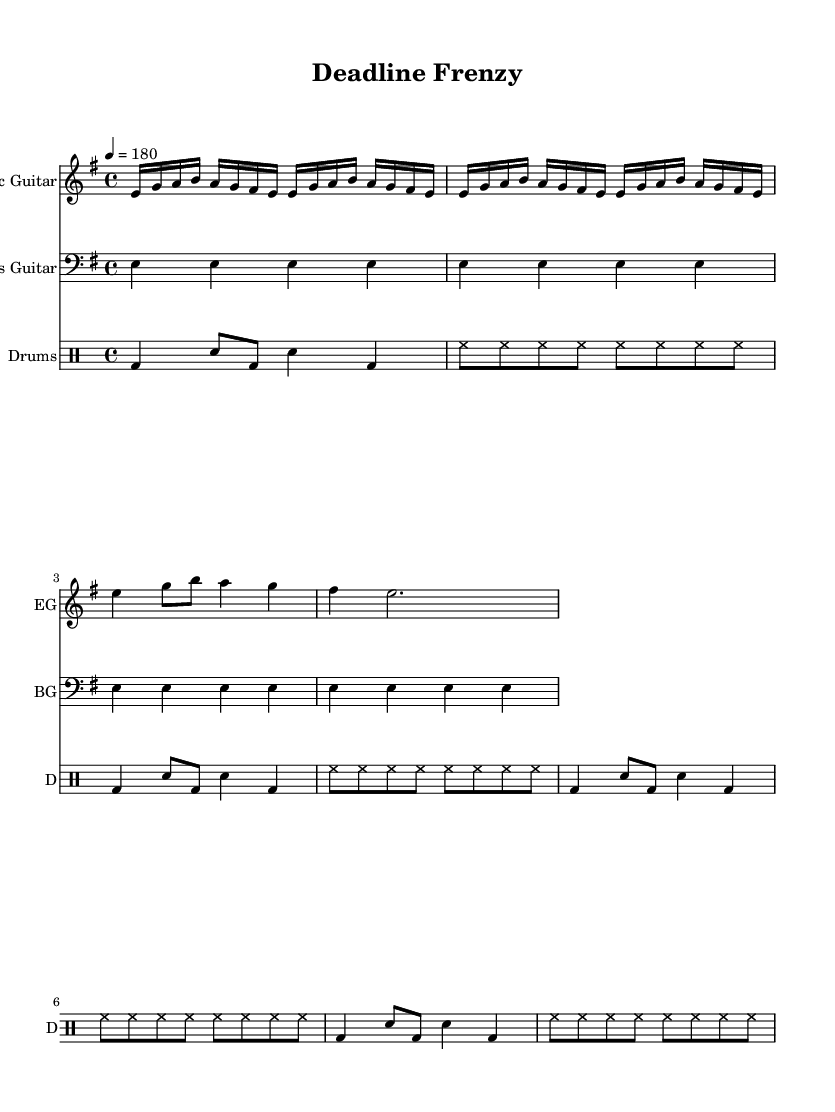What is the key signature of this music? The key signature shows one sharp, indicating that the key is E minor.
Answer: E minor What is the time signature? The time signature is indicated at the beginning of the score, displaying four beats per measure, which is common in metal music styles.
Answer: 4/4 What is the tempo marking for this piece? The tempo marking is found above the staff, indicating a fast pace of 180 beats per minute.
Answer: 180 How many measures are repeated in the main riff of the electric guitar? Looking at the electric guitar section, the main riff is repeated four times, as denoted by the repeat sign.
Answer: 4 Which instrument has the clef marked as bass? The bass guitar section is explicitly marked with the bass clef, differentiating it from other instruments in the score.
Answer: Bass Guitar What rhythm pattern does the drum section primarily use? The drum section features a repeated pattern that includes bass drum and snare drum rhythmically alternating, typical for energetic metal music.
Answer: Alternating bass and snare How many times does the chorus melody appear in the sheet? The chorus melody appears just once in the provided score as it is represented without a repeat indication.
Answer: 1 